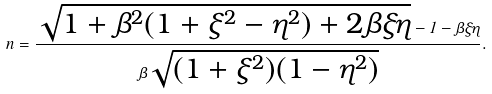Convert formula to latex. <formula><loc_0><loc_0><loc_500><loc_500>n = \frac { \sqrt { 1 + \beta ^ { 2 } ( 1 + \xi ^ { 2 } - \eta ^ { 2 } ) + 2 \beta \xi \eta } - 1 - \beta \xi \eta } { \beta \sqrt { ( 1 + \xi ^ { 2 } ) ( 1 - \eta ^ { 2 } ) } } .</formula> 